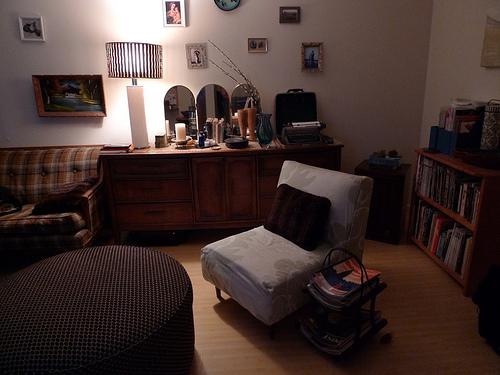Is there a mirror in this room?
Short answer required. Yes. Are the candles lit?
Concise answer only. No. What color is the wall?
Write a very short answer. White. What type of room is this?
Answer briefly. Living room. How many framed pictures are on the wall?
Write a very short answer. 8. Is this a bachelor pad?
Be succinct. No. How many chairs are in the photo?
Short answer required. 1. What color is the chair in the middle?
Be succinct. White. What shape is the rug?
Concise answer only. No rug. Is this daytime?
Answer briefly. No. What room is this?
Short answer required. Living room. Is the magazine rack empty?
Answer briefly. No. 